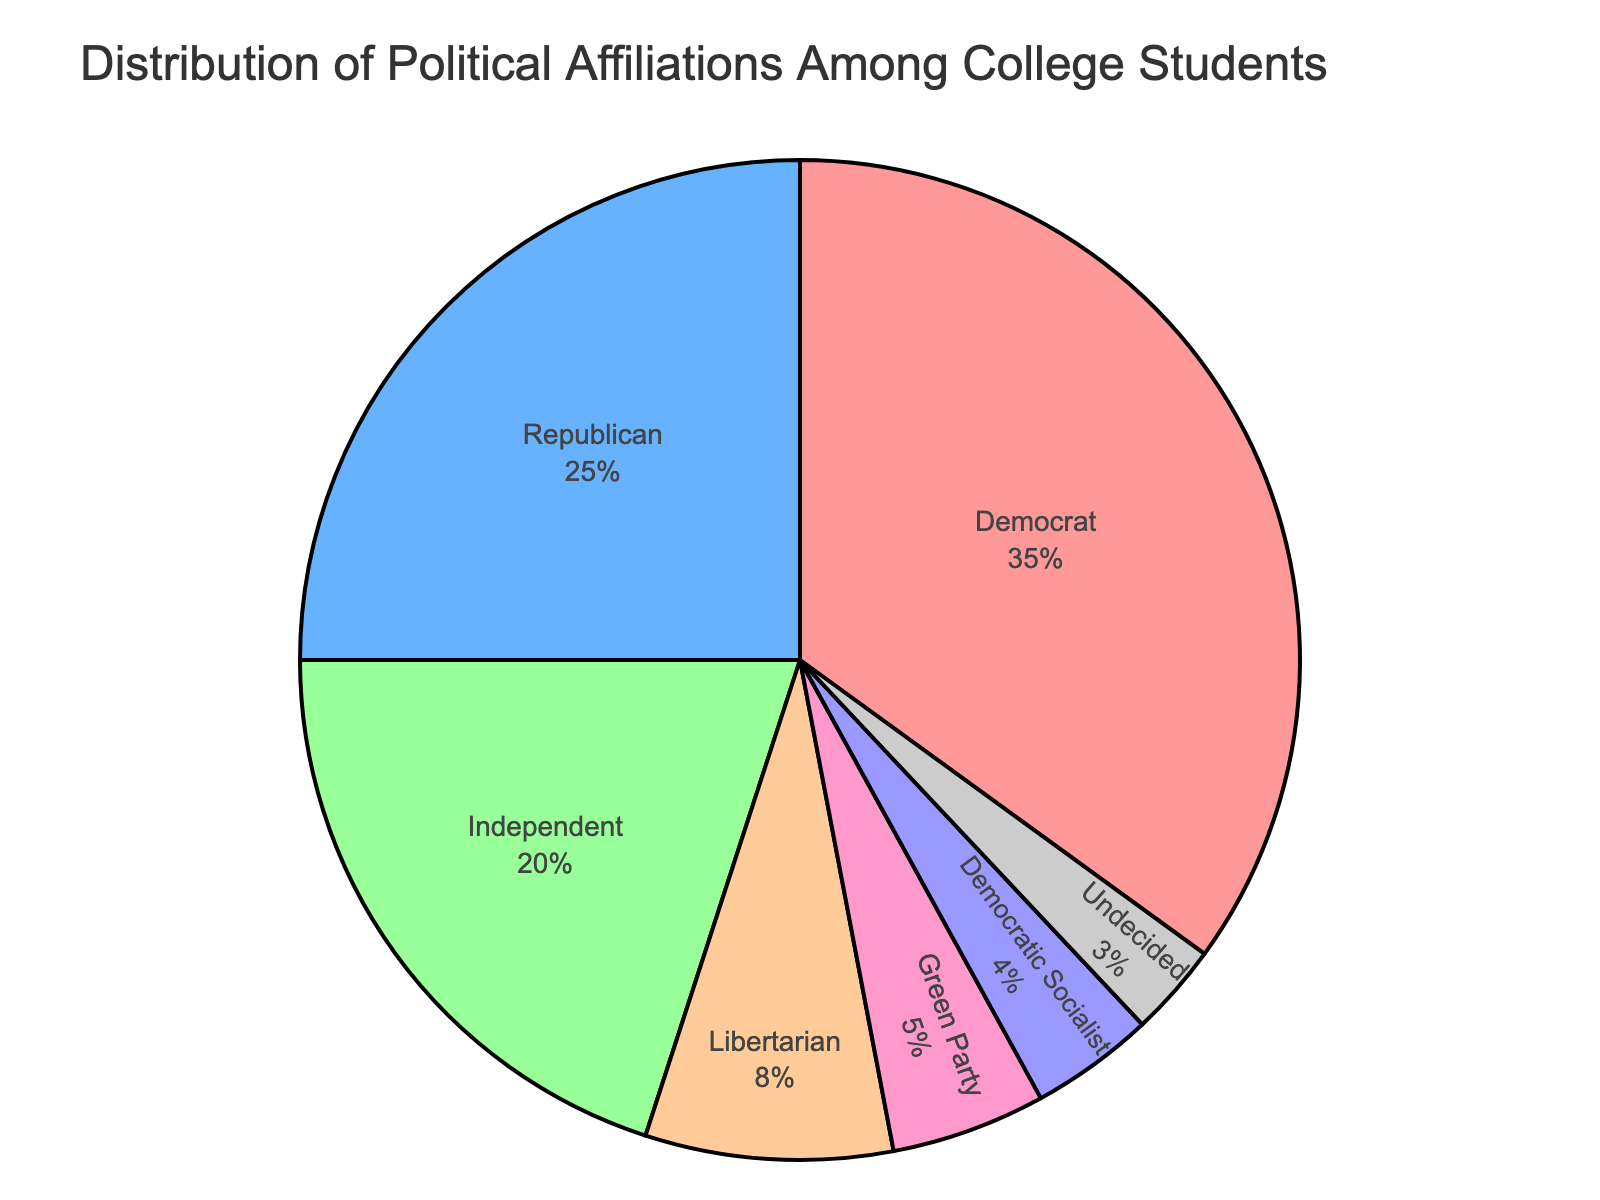which political affiliation has the largest percentage among college students? The pie chart shows that the Democrat section is the largest, indicating it has the highest percentage.
Answer: Democrat which political affiliation has the smallest percentage? The smallest section in the pie chart is the Undecided category, which occupies the least area compared to others.
Answer: Undecided what is the combined percentage of Green Party and Democratic Socialist affiliates? To find the combined percentage, add the values for Green Party and Democratic Socialist. So, 5% (Green Party) + 4% (Democratic Socialist) = 9%.
Answer: 9% how does the percentage of Independents compare to that of Libertarians? The pie chart shows Independents at 20% and Libertarians at 8%. Since 20% is greater than 8%, the percentage of Independents is higher.
Answer: Independents have a higher percentage what percentage of students are either Republican or Independent? Add the percentages of Republicans and Independents: 25% (Republican) + 20% (Independent) = 45%.
Answer: 45% how does the percentage of Democrats compare to the combined percentage of Libertarians and Green Party affiliates? Democrats are 35%. The combined percentage of Libertarians (8%) and Green Party (5%) is 8% + 5% = 13%. Since 35% > 13%, Democrats have a higher percentage.
Answer: Democrats have a higher percentage is the sum of percentages for Libertarians and Democratic Socialists greater than that of Independents? Libertarians are 8%, and Democratic Socialists are 4%, summing to 12%. Independents are 20%. Since 12% < 20%, the sum is not greater.
Answer: No what percentage do all politically affiliated groups sum to without including the undecided? Sum all percentages except Undecided: 35% (Democrat) + 25% (Republican) + 20% (Independent) + 8% (Libertarian) + 5% (Green Party) + 4% (Democratic Socialist) = 97%.
Answer: 97% what percentage is represented by groups other than Democrat and Republican? Add percentages for non-Democrat and non-Republican groups: 20% (Independent) + 8% (Libertarian) + 5% (Green Party) + 4% (Democratic Socialist) + 3% (Undecided) = 40%.
Answer: 40% if another group were to emerge and gain 10% from each of the existing groups, what would be the new percentage of Democrats? Democrats would lose 10% of their 35%: 35% - (10% of 35%) = 35% - 3.5% = 31.5%.
Answer: 31.5% 